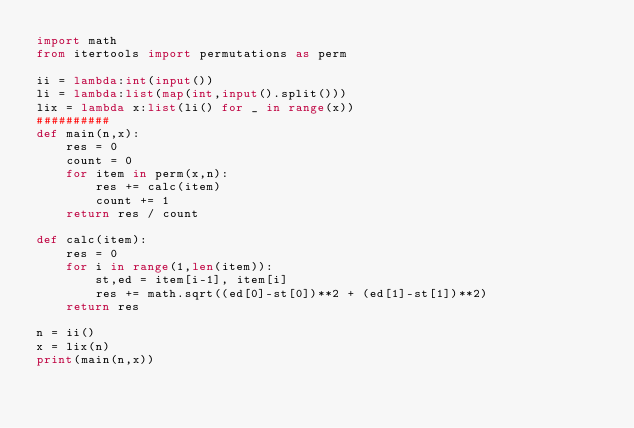Convert code to text. <code><loc_0><loc_0><loc_500><loc_500><_Python_>import math
from itertools import permutations as perm

ii = lambda:int(input())
li = lambda:list(map(int,input().split()))
lix = lambda x:list(li() for _ in range(x))
##########
def main(n,x):
    res = 0
    count = 0
    for item in perm(x,n):
        res += calc(item)
        count += 1
    return res / count
    
def calc(item):
    res = 0
    for i in range(1,len(item)):
        st,ed = item[i-1], item[i]
        res += math.sqrt((ed[0]-st[0])**2 + (ed[1]-st[1])**2)
    return res

n = ii()
x = lix(n)
print(main(n,x))</code> 